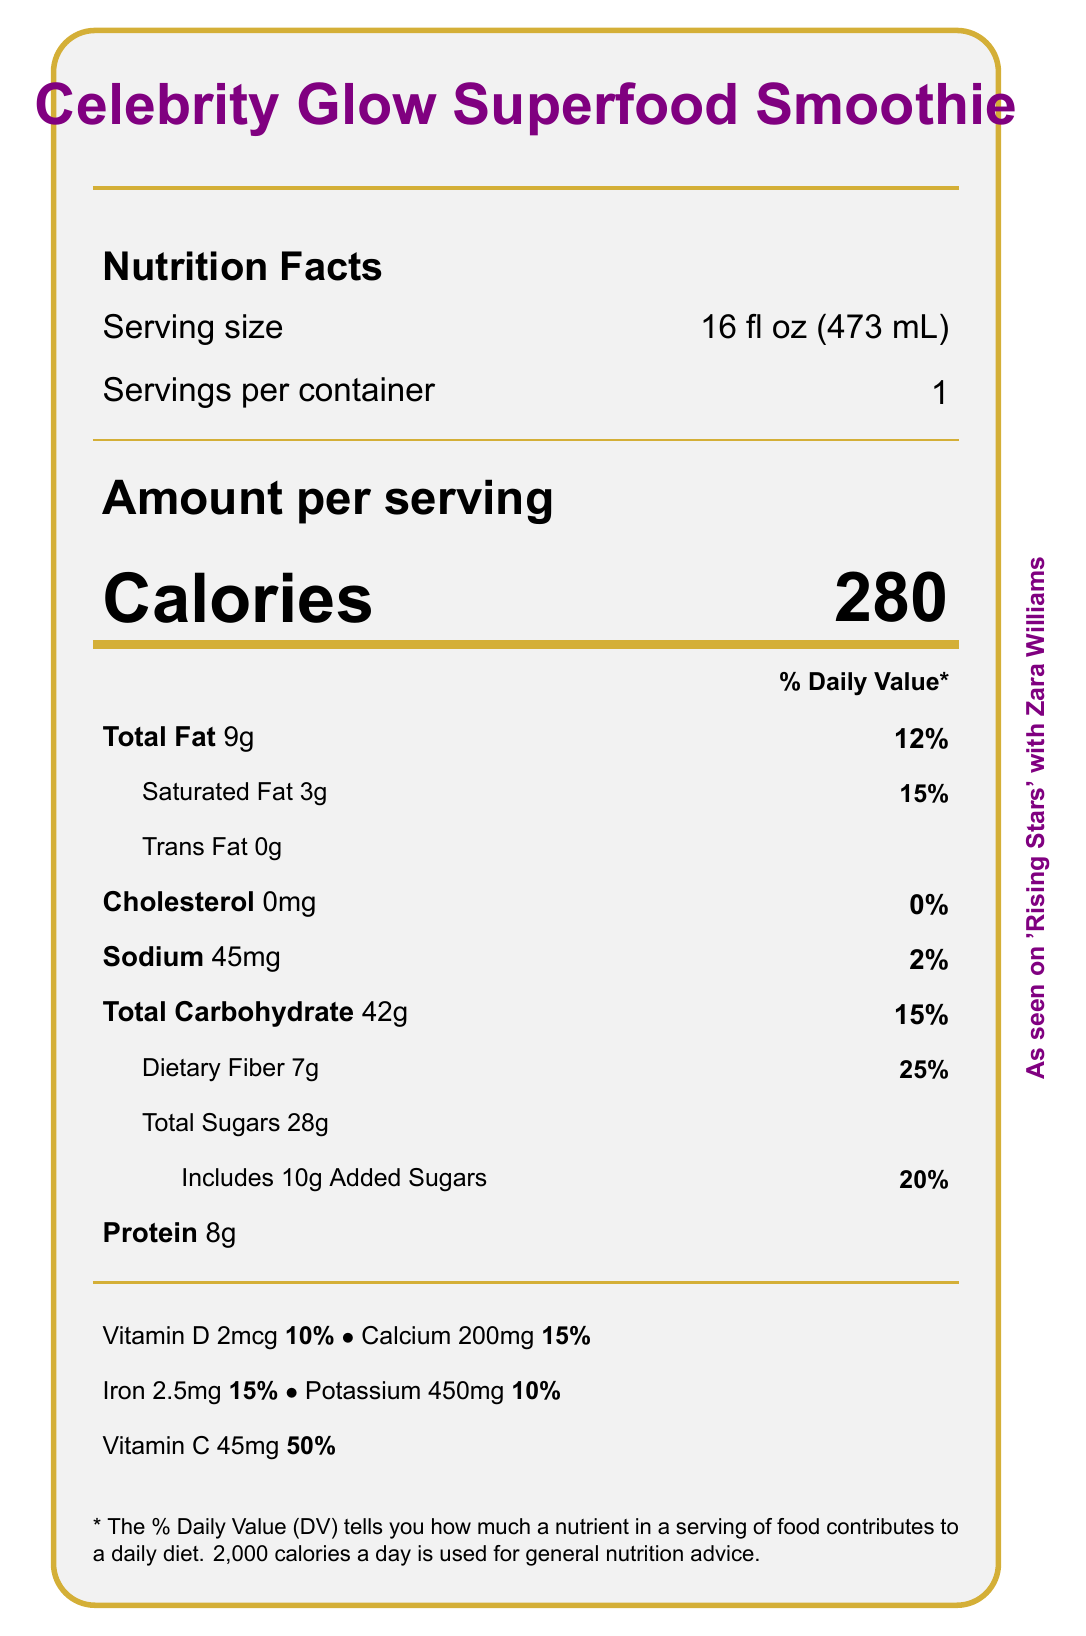what is the serving size for the Celebrity Glow Superfood Smoothie? The serving size is shown as 16 fl oz (473 mL) under the "Serving size" section.
Answer: 16 fl oz (473 mL) how many calories are in one serving of Celebrity Glow Superfood Smoothie? The document indicates that there are 280 calories per serving.
Answer: 280 what is the total carbohydrate content per serving? The total carbohydrate content is listed as 42g in the "Total Carbohydrate" section.
Answer: 42g how much dietary fiber does one serving provide? The dietary fiber content is noted as 7g under the "Dietary Fiber" subsection.
Answer: 7g are there any tree nuts in the smoothie? The "Allergens" section lists tree nuts (almonds) as an allergen.
Answer: Yes how much total fat is in the smoothie? The total fat content is identified as 9g in the "Total Fat" section.
Answer: 9g what percentage of the daily value does the added sugars contribute? The added sugars section indicates that they contribute 20% to the daily value.
Answer: 20% is the smoothie gluten-free? "Gluten-free" is listed under the "Claims" section.
Answer: Yes what is the amount of iron in the smoothie? The amount of iron is specified as 2.5mg under the Vitamin and Mineral content.
Answer: 2.5mg which vitamin has the highest daily value percentage in the smoothie? A. Vitamin D B. Vitamin C C. Calcium D. Iron Vitamin C has the highest daily value percentage at 50%, as shown under the Vitamin and Mineral content.
Answer: B. Vitamin C what is the purpose of the charitable contribution made from the profits? A. Environmental initiatives B. Animal rights C. Racial equality D. Healthcare The document states that 1% of profits are donated to racial equality initiatives.
Answer: C. Racial equality is there any cholesterol in the smoothie? The cholesterol content is listed as 0mg, contributing 0% to the daily value.
Answer: No describe the main idea of the document. The document outlines all the nutritional details, special claims, ethical sourcing, and charitable contributions related to the Celebrity Glow Superfood Smoothie, ensuring consumers are informed about what they are consuming.
Answer: The document provides detailed nutritional information for the Celebrity Glow Superfood Smoothie, including calorie content, fat, carbohydrates, protein, and vitamins. It also highlights special claims like being vegan, gluten-free, and antioxidant-rich. Additionally, it mentions ethical sourcing and a charitable contribution to racial equality initiatives. how many calories come from fat in the smoothie? The document does not provide the specific number of calories derived from fat.
Answer: Not enough information 